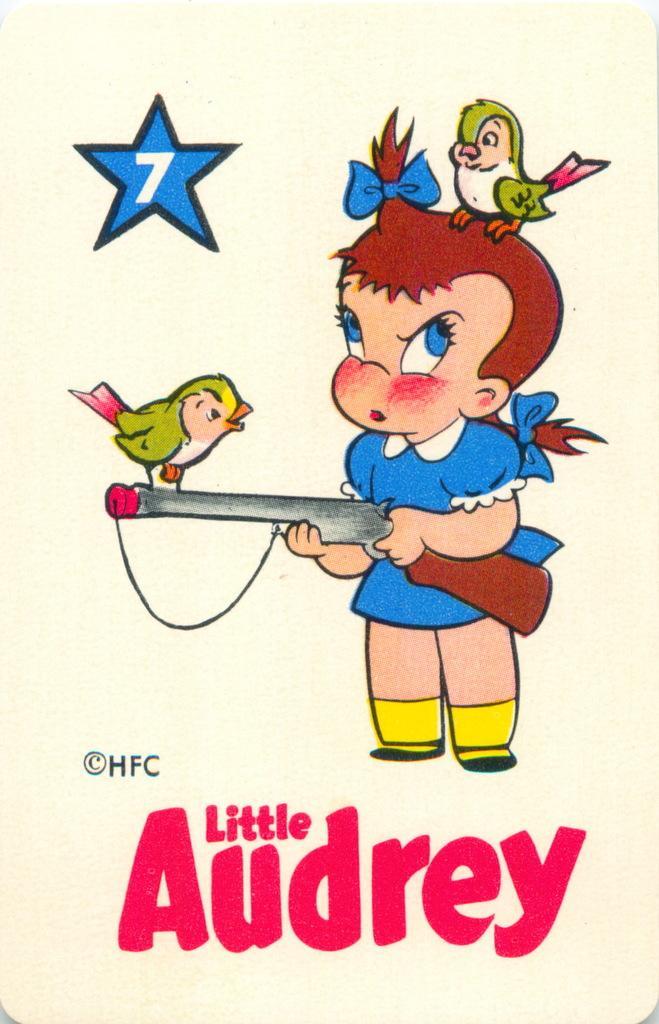Can you describe this image briefly? In this image, we can see cartoon pictures and some text on the paper. 